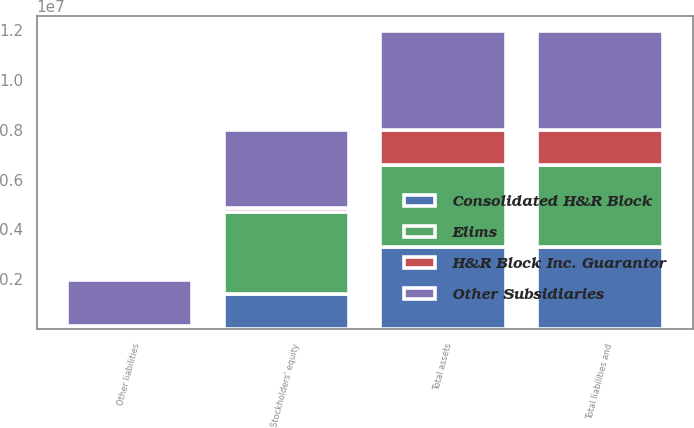<chart> <loc_0><loc_0><loc_500><loc_500><stacked_bar_chart><ecel><fcel>Total assets<fcel>Other liabilities<fcel>Stockholders' equity<fcel>Total liabilities and<nl><fcel>Consolidated H&R Block<fcel>3.28947e+06<fcel>2<fcel>1.40586e+06<fcel>3.28947e+06<nl><fcel>H&R Block Inc. Guarantor<fcel>1.41348e+06<fcel>130362<fcel>151211<fcel>1.41348e+06<nl><fcel>Other Subsidiaries<fcel>3.95243e+06<fcel>1.83648e+06<fcel>3.13822e+06<fcel>3.95243e+06<nl><fcel>Elims<fcel>3.29566e+06<fcel>12<fcel>3.28944e+06<fcel>3.29566e+06<nl></chart> 